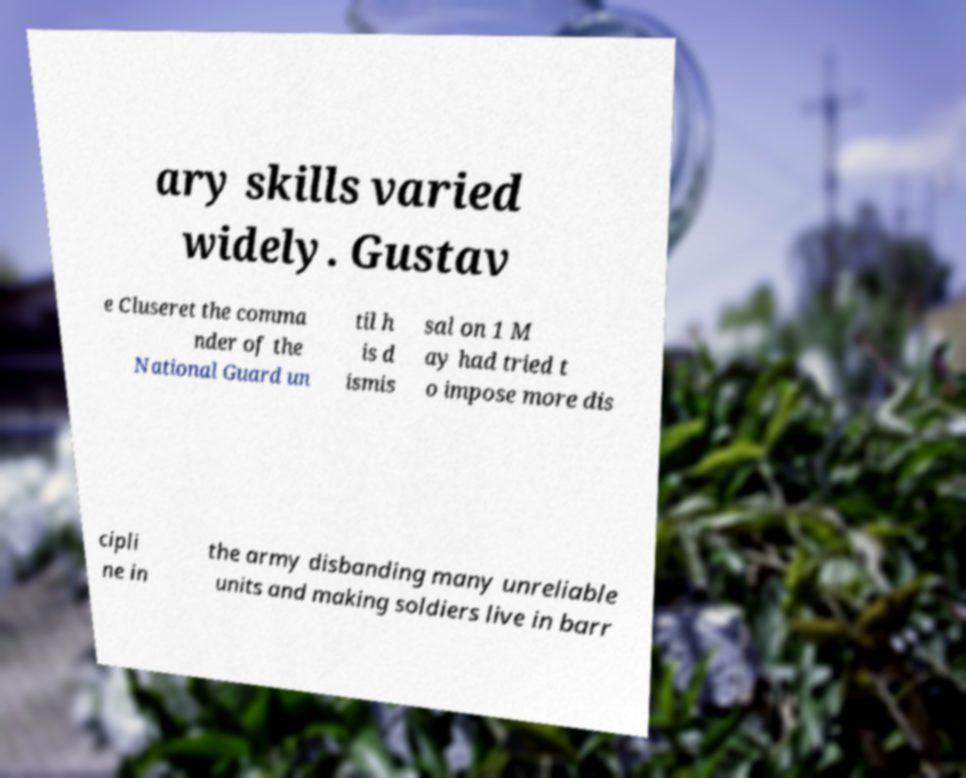Could you extract and type out the text from this image? ary skills varied widely. Gustav e Cluseret the comma nder of the National Guard un til h is d ismis sal on 1 M ay had tried t o impose more dis cipli ne in the army disbanding many unreliable units and making soldiers live in barr 